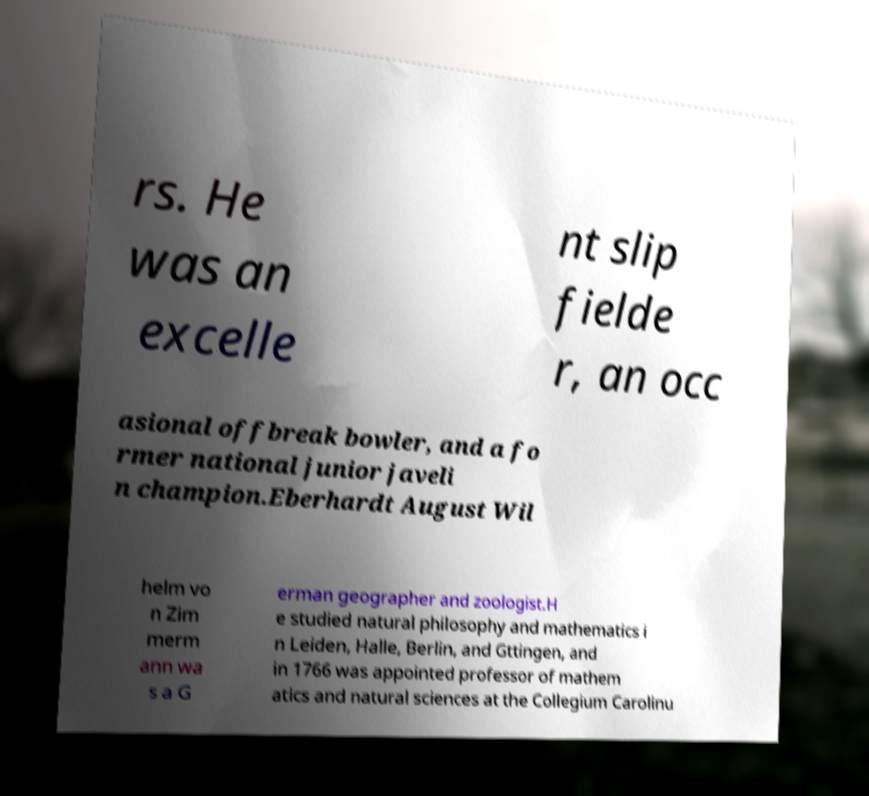What messages or text are displayed in this image? I need them in a readable, typed format. rs. He was an excelle nt slip fielde r, an occ asional offbreak bowler, and a fo rmer national junior javeli n champion.Eberhardt August Wil helm vo n Zim merm ann wa s a G erman geographer and zoologist.H e studied natural philosophy and mathematics i n Leiden, Halle, Berlin, and Gttingen, and in 1766 was appointed professor of mathem atics and natural sciences at the Collegium Carolinu 